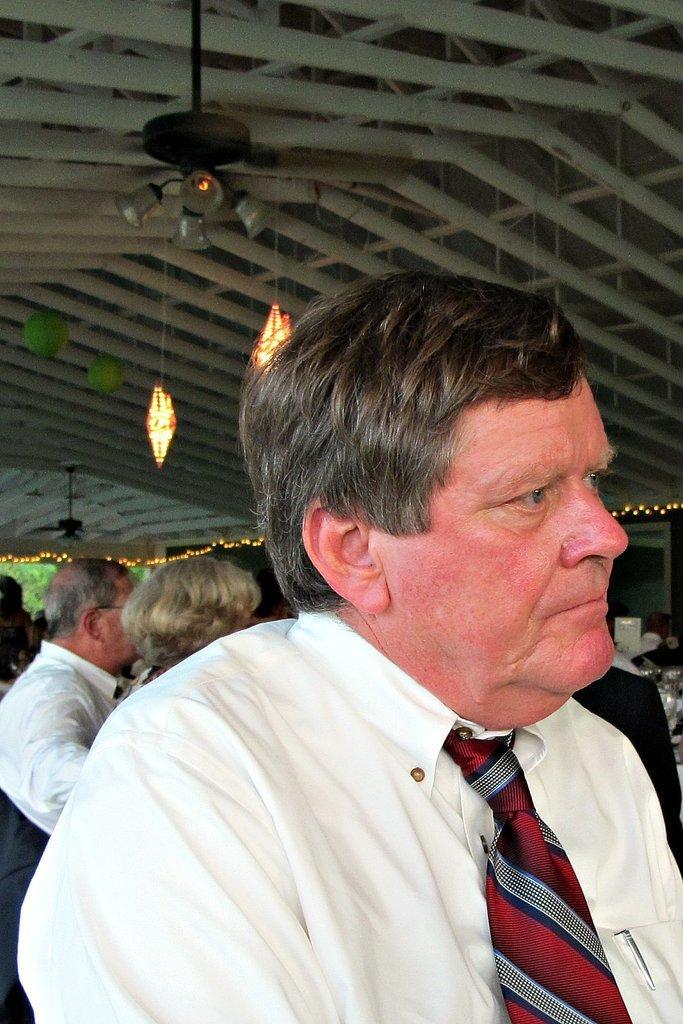How would you summarize this image in a sentence or two? In this picture I can see a man in front who is wearing white shirt and a tie. In the background I can see few people. On the top of this picture I can see the lights and I can see the rods. 